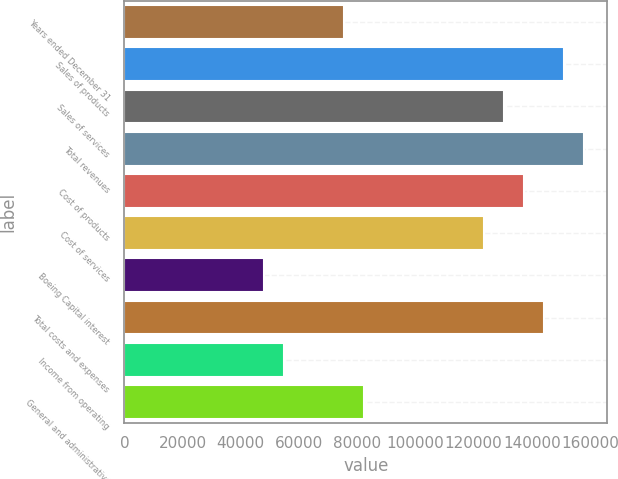Convert chart. <chart><loc_0><loc_0><loc_500><loc_500><bar_chart><fcel>Years ended December 31<fcel>Sales of products<fcel>Sales of services<fcel>Total revenues<fcel>Cost of products<fcel>Cost of services<fcel>Boeing Capital interest<fcel>Total costs and expenses<fcel>Income from operating<fcel>General and administrative<nl><fcel>75608<fcel>151211<fcel>130592<fcel>158084<fcel>137465<fcel>123719<fcel>48116.1<fcel>144338<fcel>54989.1<fcel>82481<nl></chart> 